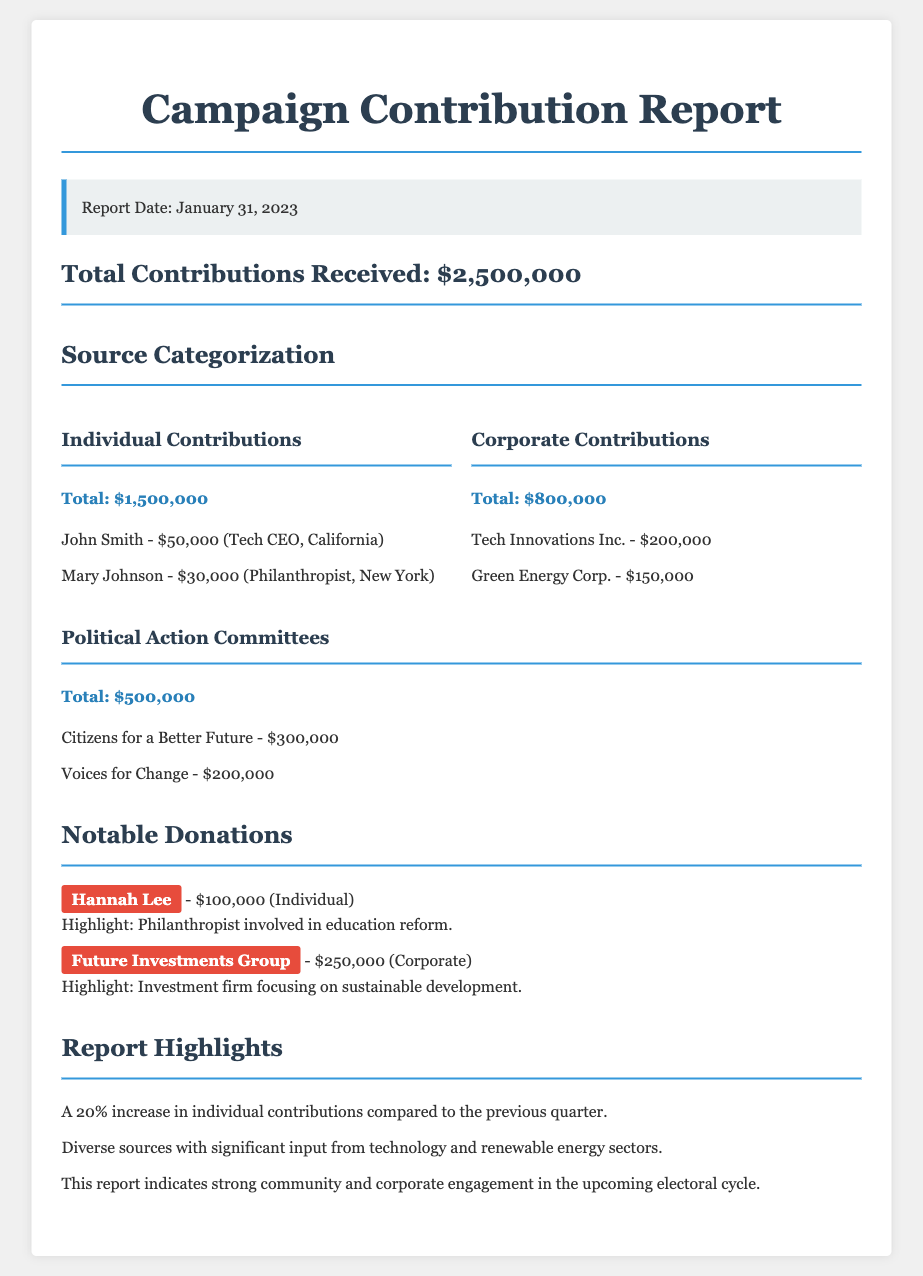What is the total contributions received? The total contributions received is stated in the report, which is $2,500,000.
Answer: $2,500,000 How much was contributed by individuals? The document specifies the total contributions from individuals as $1,500,000.
Answer: $1,500,000 Who made the largest individual contribution? The report lists the largest individual contribution as $100,000 by Hannah Lee.
Answer: Hannah Lee What is the total amount from corporate contributions? Corporate contributions are summed up in the document to a total of $800,000.
Answer: $800,000 What notable contribution did Future Investments Group make? Future Investments Group is noted in the report for donating $250,000.
Answer: $250,000 What was the percentage increase in individual contributions compared to the previous quarter? The document highlights a percentage increase of 20% in individual contributions.
Answer: 20% Which area saw significant contributions according to the report highlights? The report indicates significant contributions from the technology and renewable energy sectors.
Answer: Technology and renewable energy sectors What two organizations contributed the most among Political Action Committees? The two organizations with the highest contributions are Citizens for a Better Future and Voices for Change, totaling $300,000 and $200,000, respectively.
Answer: Citizens for a Better Future and Voices for Change 